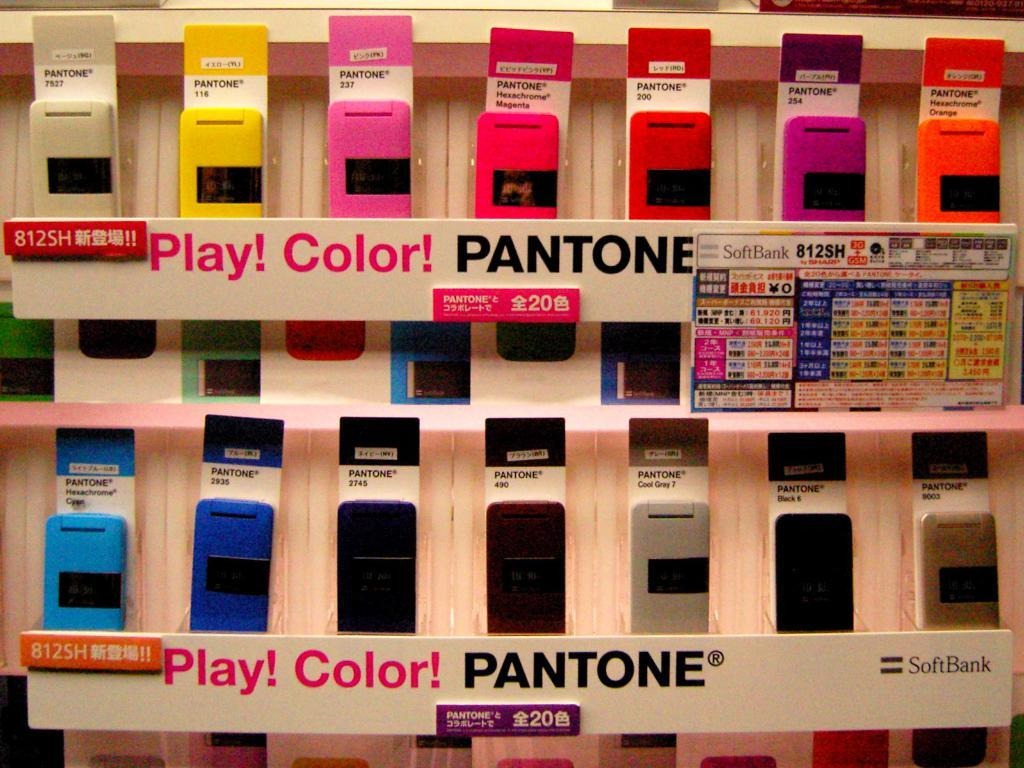Provide a one-sentence caption for the provided image. A Pantone display with many different colors that says Play!. 